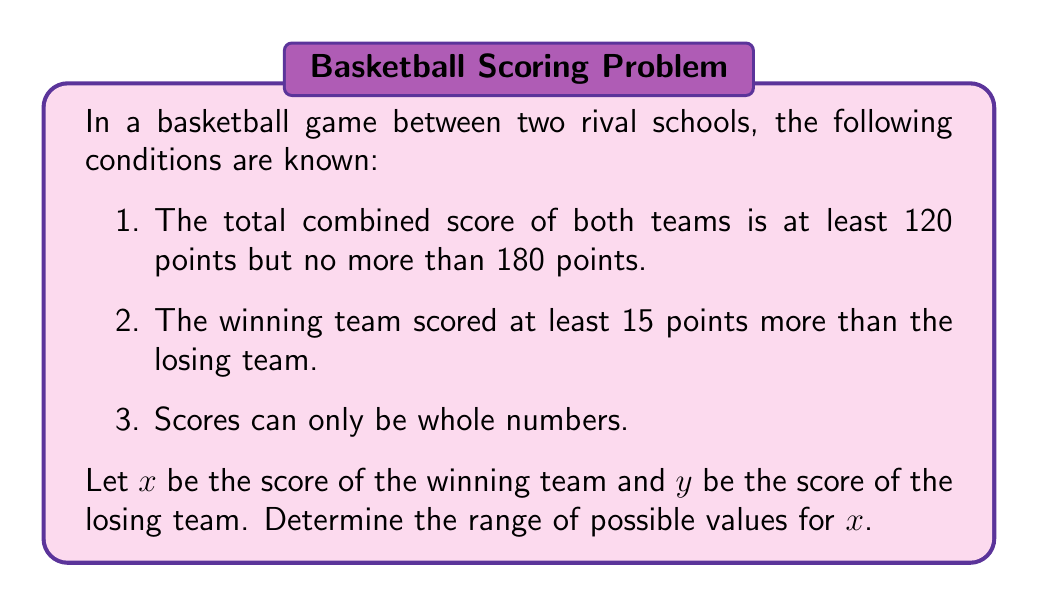Solve this math problem. Let's approach this step-by-step:

1) First, let's express the given conditions mathematically:
   a) $120 \leq x + y \leq 180$
   b) $x \geq y + 15$
   c) $x$ and $y$ are integers

2) From condition (b), we can say that $y \leq x - 15$

3) Substituting this into the lower bound of condition (a):
   $120 \leq x + (x - 15)$
   $120 \leq 2x - 15$
   $135 \leq 2x$
   $67.5 \leq x$

   Since $x$ must be an integer, the minimum value for $x$ is 68.

4) For the upper bound, we need to consider that $y$ must be at least 1:
   $x + y \leq 180$
   $x + 1 \leq 180$
   $x \leq 179$

5) However, we also need to check if this satisfies condition (b):
   $179 \geq y + 15$
   $164 \geq y$

   This is possible, so 179 is indeed the maximum value for $x$.

Therefore, the range of possible values for $x$ is all integers from 68 to 179, inclusive.
Answer: The range of possible values for the winning team's score ($x$) is $68 \leq x \leq 179$, where $x$ is an integer. 